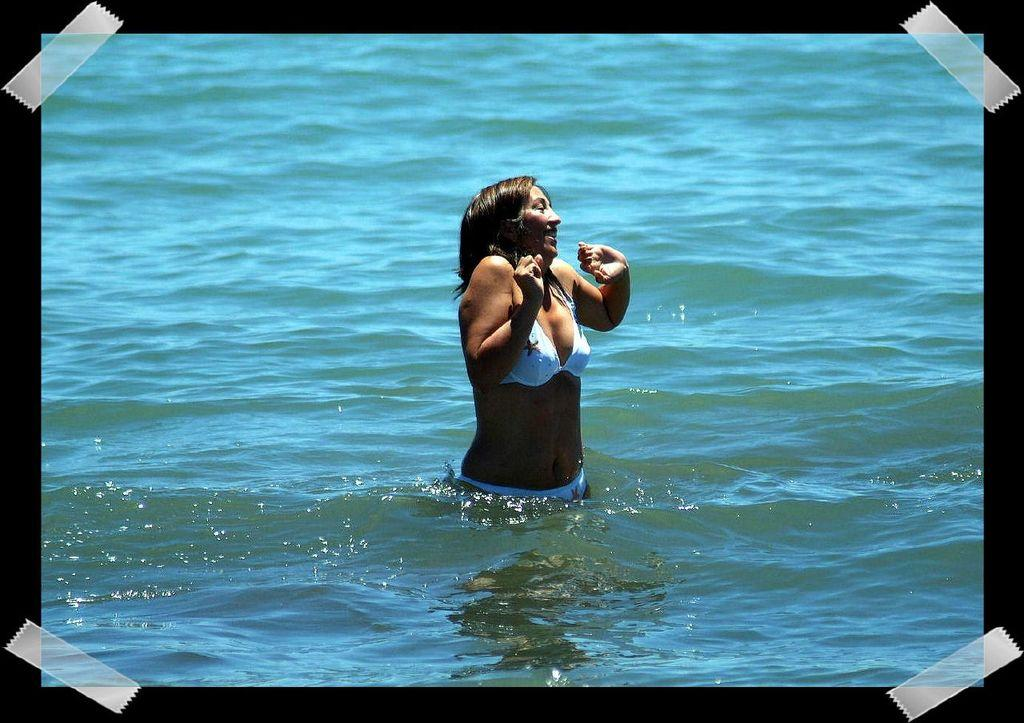What is the main subject of the image? There is a photo in the image. What can be seen in the photo? The photo contains a woman. What is the woman doing in the photo? The woman is in the water. What is the woman wearing in the photo? The woman is wearing a white color swimming suit. How many cannons are visible in the image? There are no cannons present in the image. What type of print can be seen on the woman's swimming suit? The woman's swimming suit is described as white color, but there is no mention of any print on it. 